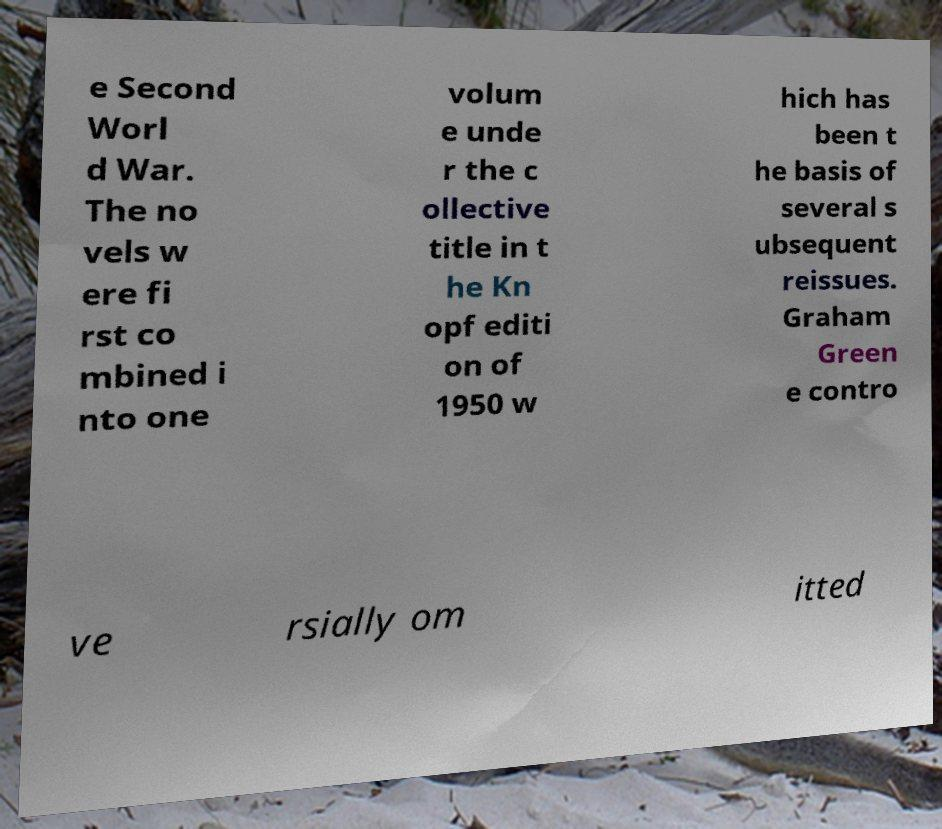For documentation purposes, I need the text within this image transcribed. Could you provide that? e Second Worl d War. The no vels w ere fi rst co mbined i nto one volum e unde r the c ollective title in t he Kn opf editi on of 1950 w hich has been t he basis of several s ubsequent reissues. Graham Green e contro ve rsially om itted 